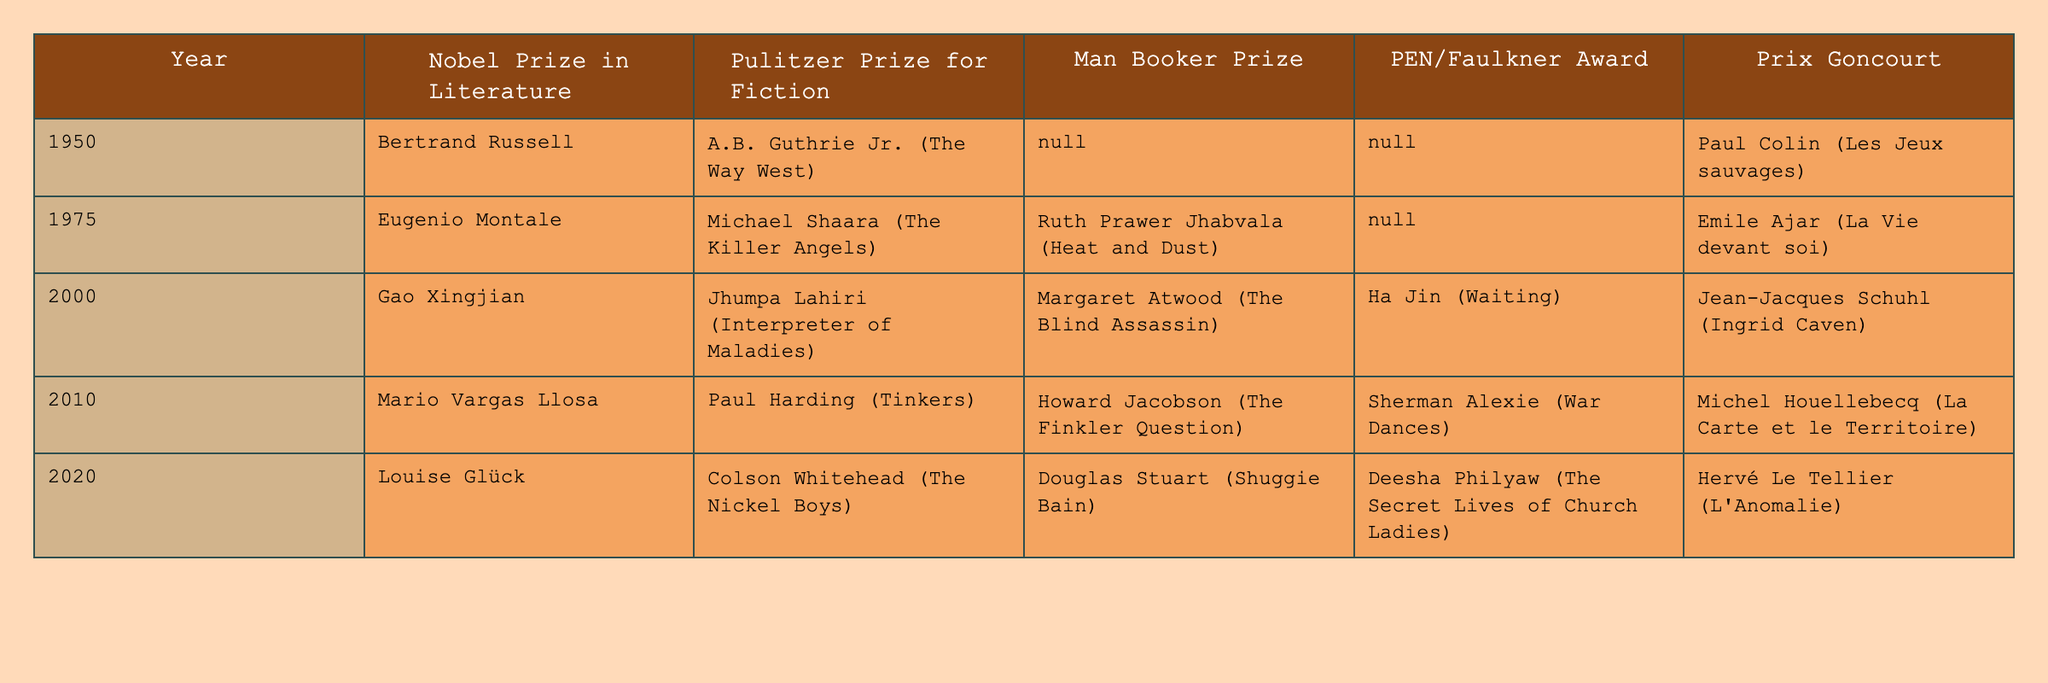What year did Louise Glück win the Nobel Prize in Literature? Louise Glück is listed under the "Nobel Prize in Literature" column for the year 2020 in the table.
Answer: 2020 Who won the Pulitzer Prize for Fiction in 2000? The table indicates that Jhumpa Lahiri won the Pulitzer Prize for Fiction in 2000.
Answer: Jhumpa Lahiri Which author received the Man Booker Prize in 2010? The entry for 2010 in the Man Booker Prize column shows that Howard Jacobson was the recipient.
Answer: Howard Jacobson Did Emile Ajar win any awards in 1975? The table confirms that Emile Ajar won the Prix Goncourt in 1975.
Answer: Yes What is the most recent year listed in the table that features a recipient for the PEN/Faulkner Award? The last year in the table with a recipient for the PEN/Faulkner Award is 2020, where Deesha Philyaw is mentioned.
Answer: 2020 Which year had the highest number of awards listed, and how many were there? The year 2000 has awards for all five categories: Nobel Prize, Pulitzer Prize, Man Booker Prize, PEN/Faulkner Award, and Prix Goncourt, totaling five awards.
Answer: 2000, 5 Which author won both the Nobel Prize and the Pulitzer Prize in the same century? Bertrand Russell won the Nobel Prize in 1950 while Michael Shaara won the Pulitzer Prize in the same century but in a different year (1975). Bertrand Russell is the only one who won a Nobel Prize but not both in the same year.
Answer: None How many different authors won the Pulitzer Prize for Fiction in the years 2000 and 2020 combined? Jhumpa Lahiri won in 2000 and Colson Whitehead won in 2020, giving a total of two unique authors for these years.
Answer: 2 In which year did a recipient of the Prix Goncourt also receive the Nobel Prize? The years 1950 and 2020 both show a winner for the Prix Goncourt (Paul Colin and Hervé Le Tellier) and a Nobel Prize (Bertrand Russell and Louise Glück), respectively; however, they did not win in the same year.
Answer: None Was the recipient of the PEN/Faulkner Award in 2010 also awarded the Man Booker Prize that year? The table shows that Sherman Alexie received the PEN/Faulkner Award in 2010, while Howard Jacobson won the Man Booker Prize, indicating they are different authors.
Answer: No 